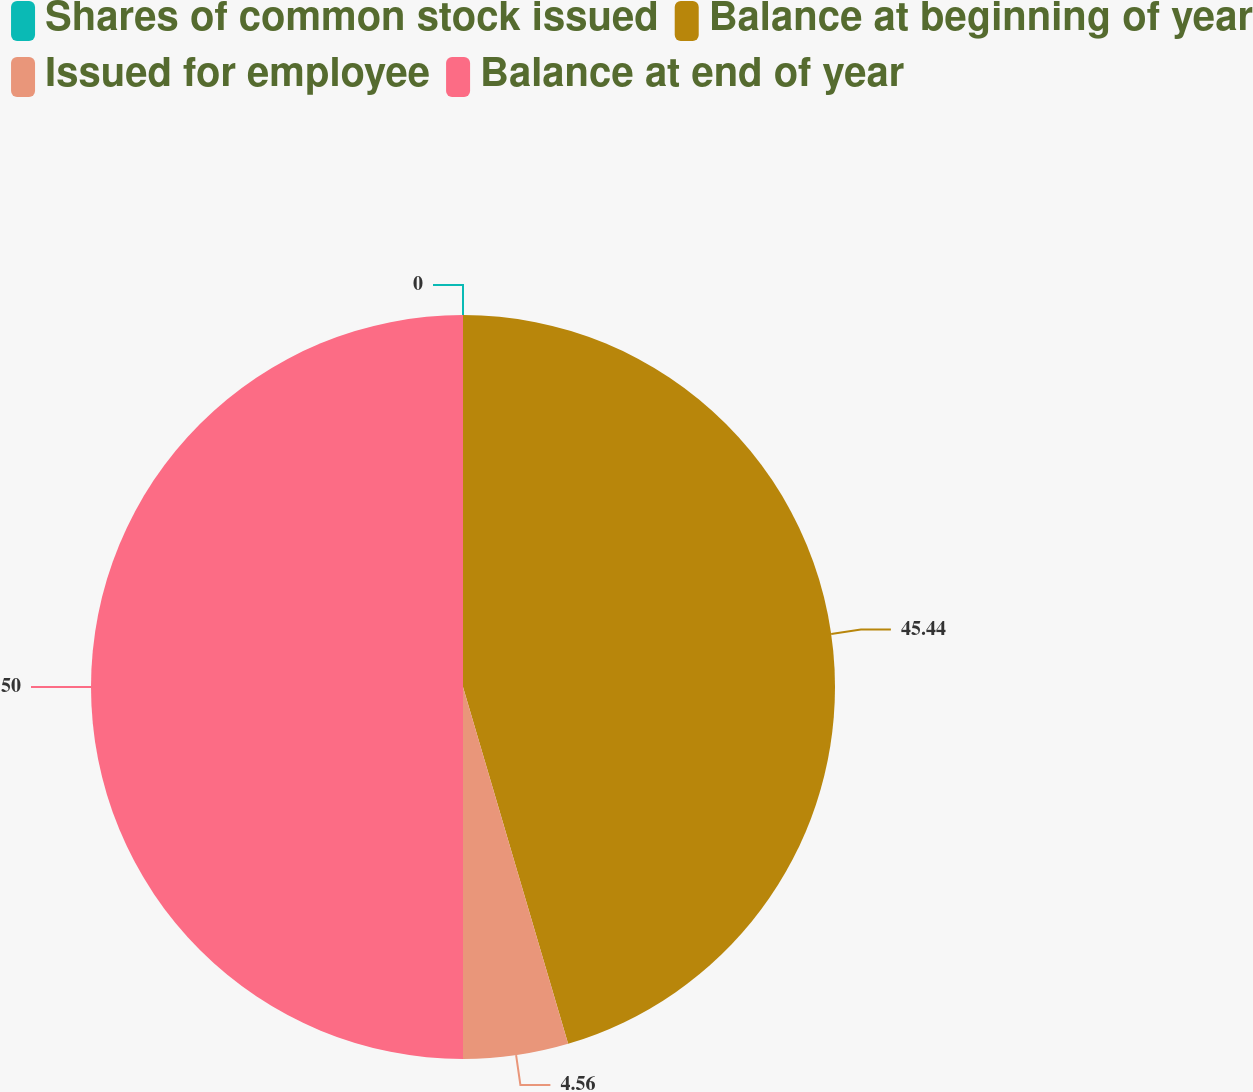<chart> <loc_0><loc_0><loc_500><loc_500><pie_chart><fcel>Shares of common stock issued<fcel>Balance at beginning of year<fcel>Issued for employee<fcel>Balance at end of year<nl><fcel>0.0%<fcel>45.44%<fcel>4.56%<fcel>50.0%<nl></chart> 